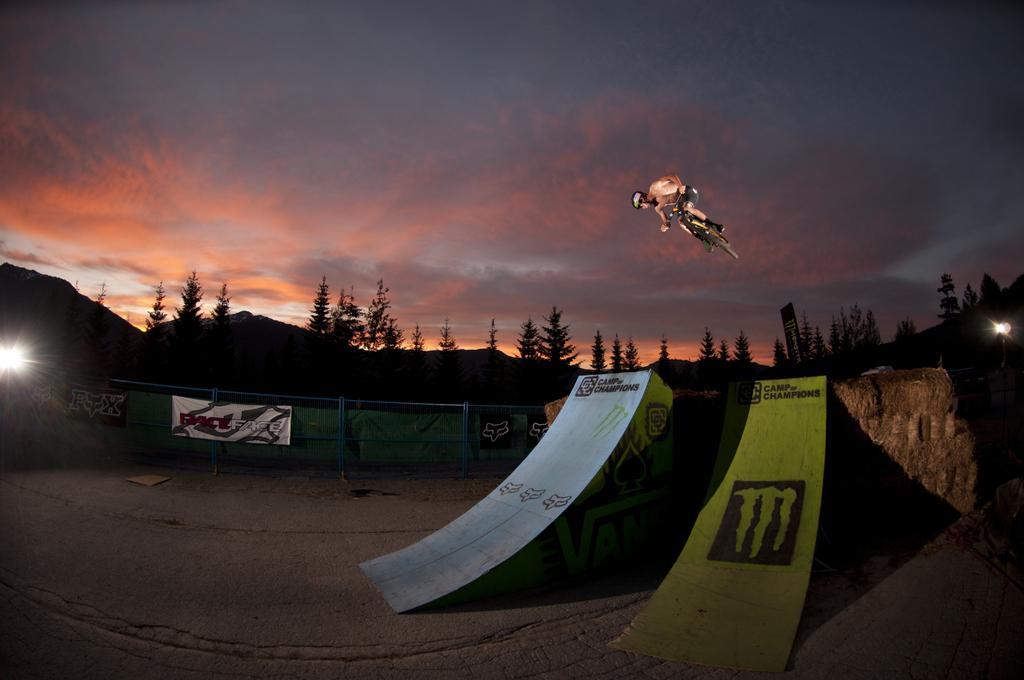Could you give a brief overview of what you see in this image? In the middle of the image there is a fencing, on the fencing there are some banners. Behind the fencing there are some trees and hills and poles. At the top of the image a person is riding a bicycle and jumping. Behind him there are some clouds in the sky. 